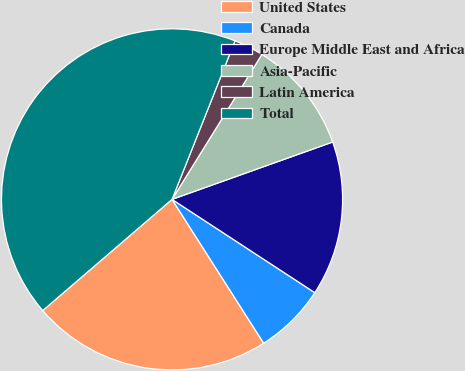<chart> <loc_0><loc_0><loc_500><loc_500><pie_chart><fcel>United States<fcel>Canada<fcel>Europe Middle East and Africa<fcel>Asia-Pacific<fcel>Latin America<fcel>Total<nl><fcel>22.72%<fcel>6.76%<fcel>14.67%<fcel>10.71%<fcel>2.81%<fcel>42.32%<nl></chart> 